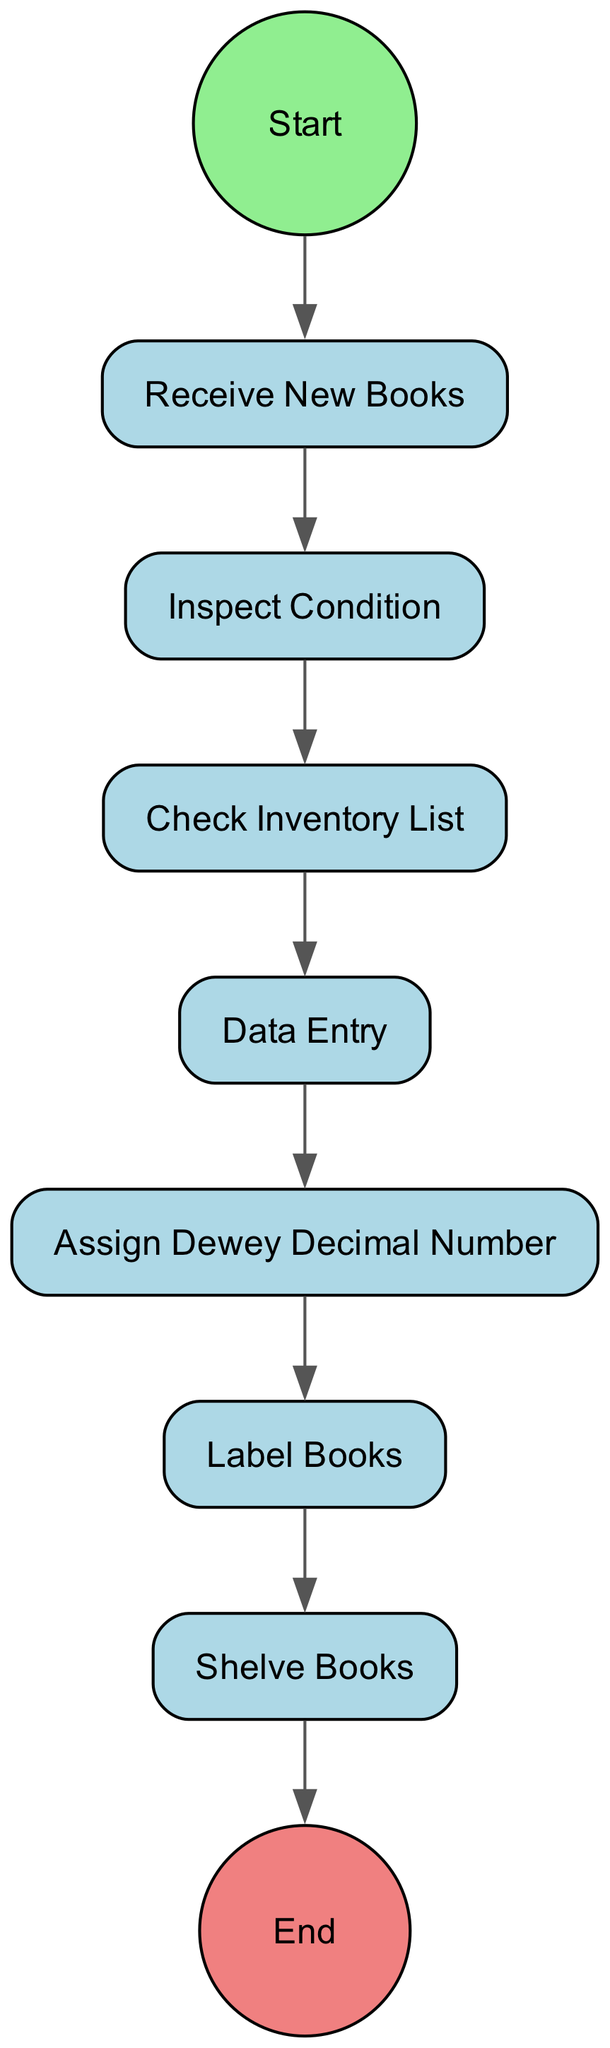What is the first activity in the process? The first activity is indicated by the outgoing transition from the "Start" node. The diagram begins with "Receive New Books," meaning this is the initial step in the cataloging and shelving process.
Answer: Receive New Books How many activities are there in this diagram? The diagram lists a total of seven distinct activities that are part of the process. These activities are individually defined, which allows for a comprehensive overview.
Answer: Seven What happens after "Inspect Condition"? The diagram shows that after "Inspect Condition," the next activity is "Check Inventory List." This transition indicates that the inspection leads directly into checking that the inventory aligns with what has been received.
Answer: Check Inventory List Which node comes immediately before "Shelve Books"? Analyzing the outgoing transitions, "Label Books" is the activity that directly precedes "Shelve Books." This means that the labeling has to be completed before the books can be shelved.
Answer: Label Books What is the final step in the process outlined by the diagram? The last node as shown in the diagram, where there is no outgoing transition, indicates the endpoint of the activity flow. The final step is "Shelve Books," which completes the process of cataloging new books.
Answer: Shelve Books What is the relationship between "Data Entry" and "Assign Dewey Decimal Number"? The outgoing transition from "Data Entry" leads directly to "Assign Dewey Decimal Number," which means that entering the book details is a prerequisite for assigning the appropriate classification number to each book.
Answer: Direct transition How many times does the activity "Check Inventory List" appear in the diagram? The activity "Check Inventory List" is mentioned only once in the diagram, as each activity is listed individually, and there are no repetitions for this specific node.
Answer: Once What type of diagram is this? This diagram is specifically an Activity Diagram, which visualizes the workflow or process consisting of various activities and their order.
Answer: Activity Diagram 